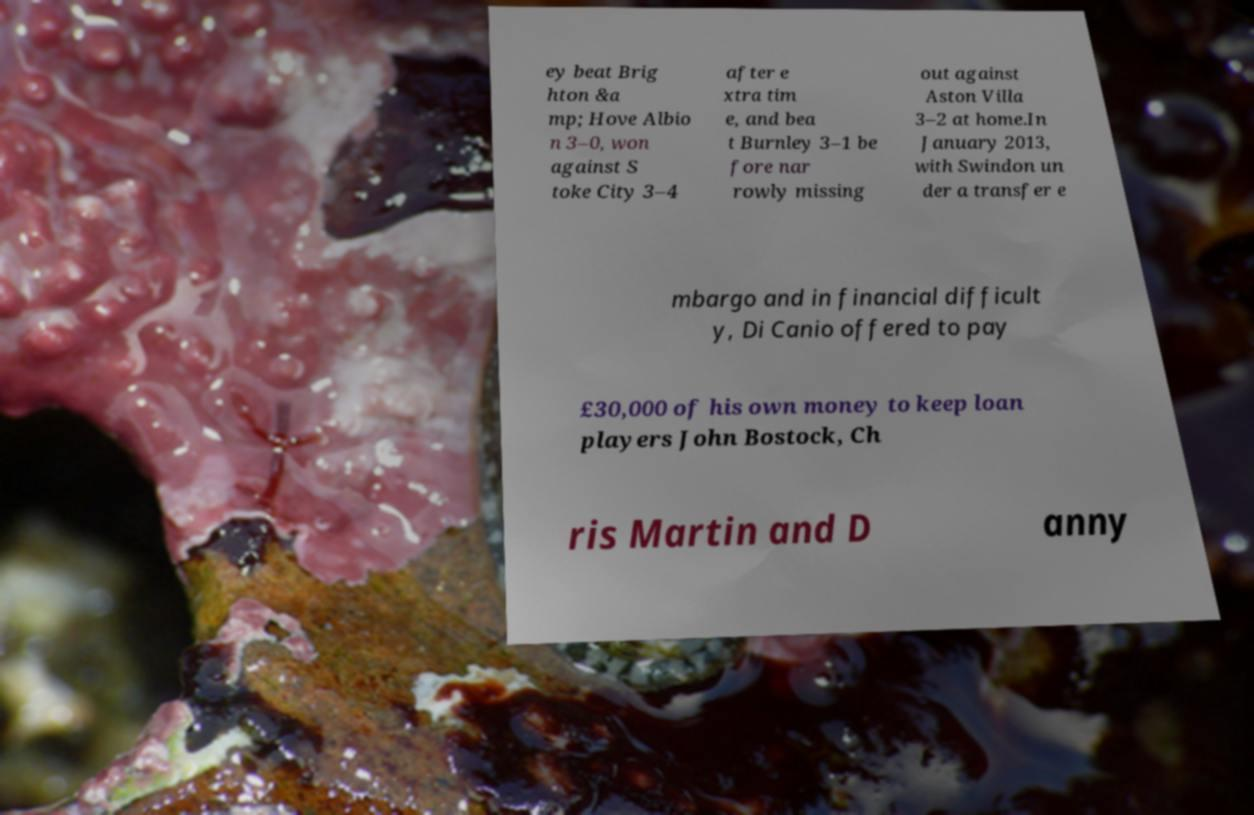What messages or text are displayed in this image? I need them in a readable, typed format. ey beat Brig hton &a mp; Hove Albio n 3–0, won against S toke City 3–4 after e xtra tim e, and bea t Burnley 3–1 be fore nar rowly missing out against Aston Villa 3–2 at home.In January 2013, with Swindon un der a transfer e mbargo and in financial difficult y, Di Canio offered to pay £30,000 of his own money to keep loan players John Bostock, Ch ris Martin and D anny 